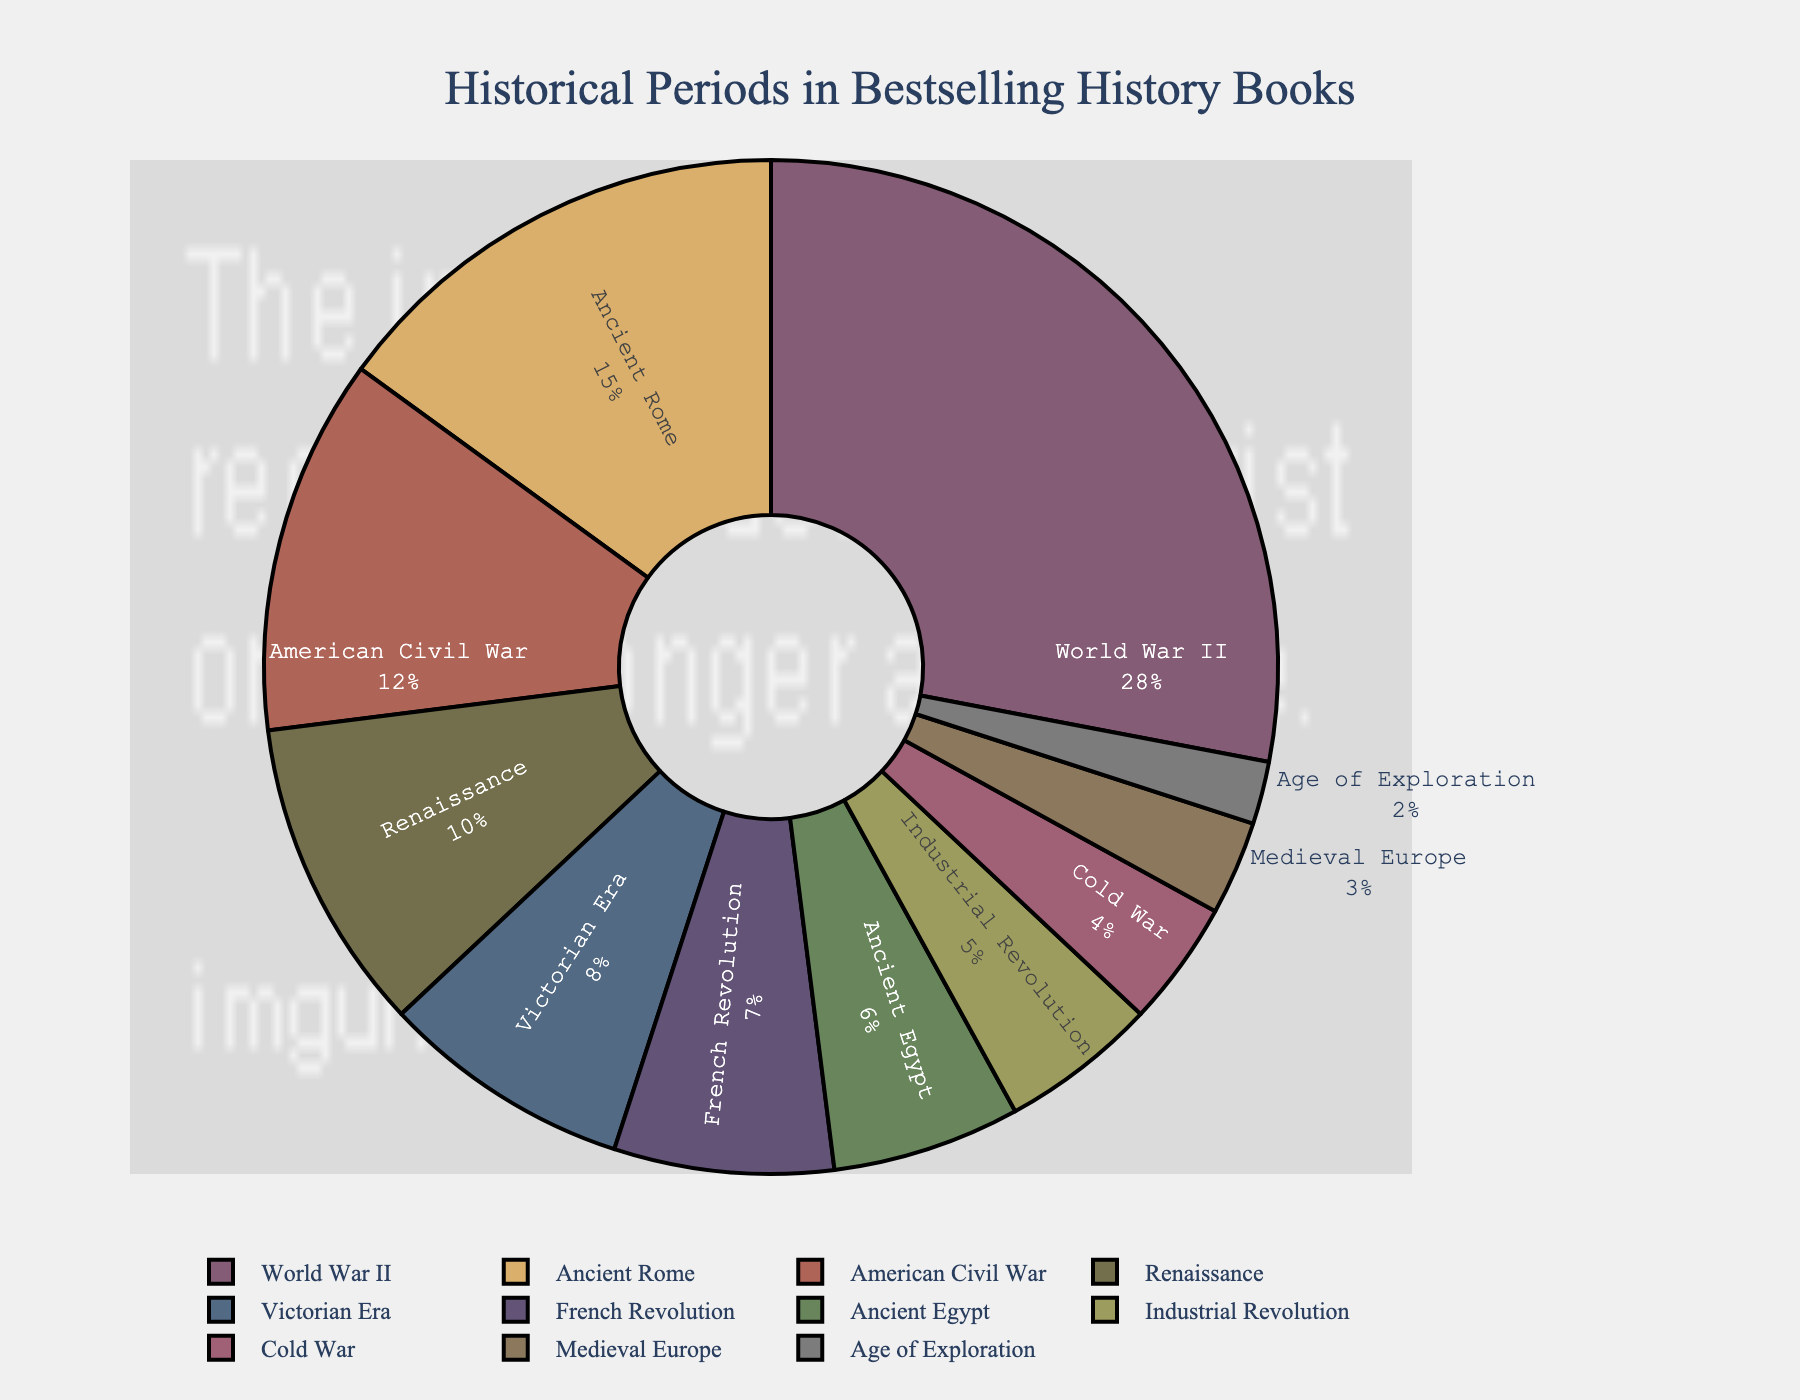What percentage of bestselling history books are about World War II? Look at the slice labeled 'World War II' and note the percentage shown, which is 28%.
Answer: 28% Which two periods together account for the largest percentage of bestselling history books? Identify the largest individual slices and sum their percentages: 'World War II' (28%) and 'Ancient Rome' (15%), which together account for 43%.
Answer: World War II and Ancient Rome How many periods each represent less than 10% of the bestselling history books? Identify slices with percentages less than 10%: American Civil War (12%), Renaissance (10%), but not included. Victorian Era (8%), French Revolution (7%), Ancient Egypt (6%), Industrial Revolution (5%), Cold War (4%), Medieval Europe (3%), Age of Exploration (2%). Count these periods, totaling 8.
Answer: 8 What is the combined percentage of bestselling history books represented by the French Revolution and the Industrial Revolution? Add the percentages for 'French Revolution' (7%) and 'Industrial Revolution' (5%) to get 12%.
Answer: 12% Which historical period has the smallest representation in bestselling history books, and what is its percentage? Look for the smallest slice and label it, which is 'Age of Exploration' with 2%.
Answer: Age of Exploration, 2% Is the percentage of books about the American Civil War more or less than half the percentage about World War II? Compare the percentages: American Civil War (12%) and World War II (28%). 12% is less than half of 28%.
Answer: Less By how much does the percentage of Ancient Rome exceed that of the Cold War? Subtract the Cold War percentage (4%) from Ancient Rome's percentage (15%). 15% - 4% = 11%.
Answer: 11% If a new period were added to the chart with a 5% share, how would this affect the percentage represented by World War II? The current total percentage of all periods sums to 100%. Adding a 5% share would make the total 105%, so the percentage of World War II would be recalculated as (28/105) * 100%, approximately 26.67%.
Answer: Approximately 26.67% Among the periods with less than 10% representation, which one has the highest percentage? Identify the highest percentage among the periods with less than 10%: Victorian Era (8%), French Revolution (7%), Ancient Egypt (6%), Industrial Revolution (5%), Cold War (4%), Medieval Europe (3%), Age of Exploration (2%). Victorian Era has the highest at 8%.
Answer: Victorian Era 